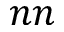<formula> <loc_0><loc_0><loc_500><loc_500>n n</formula> 